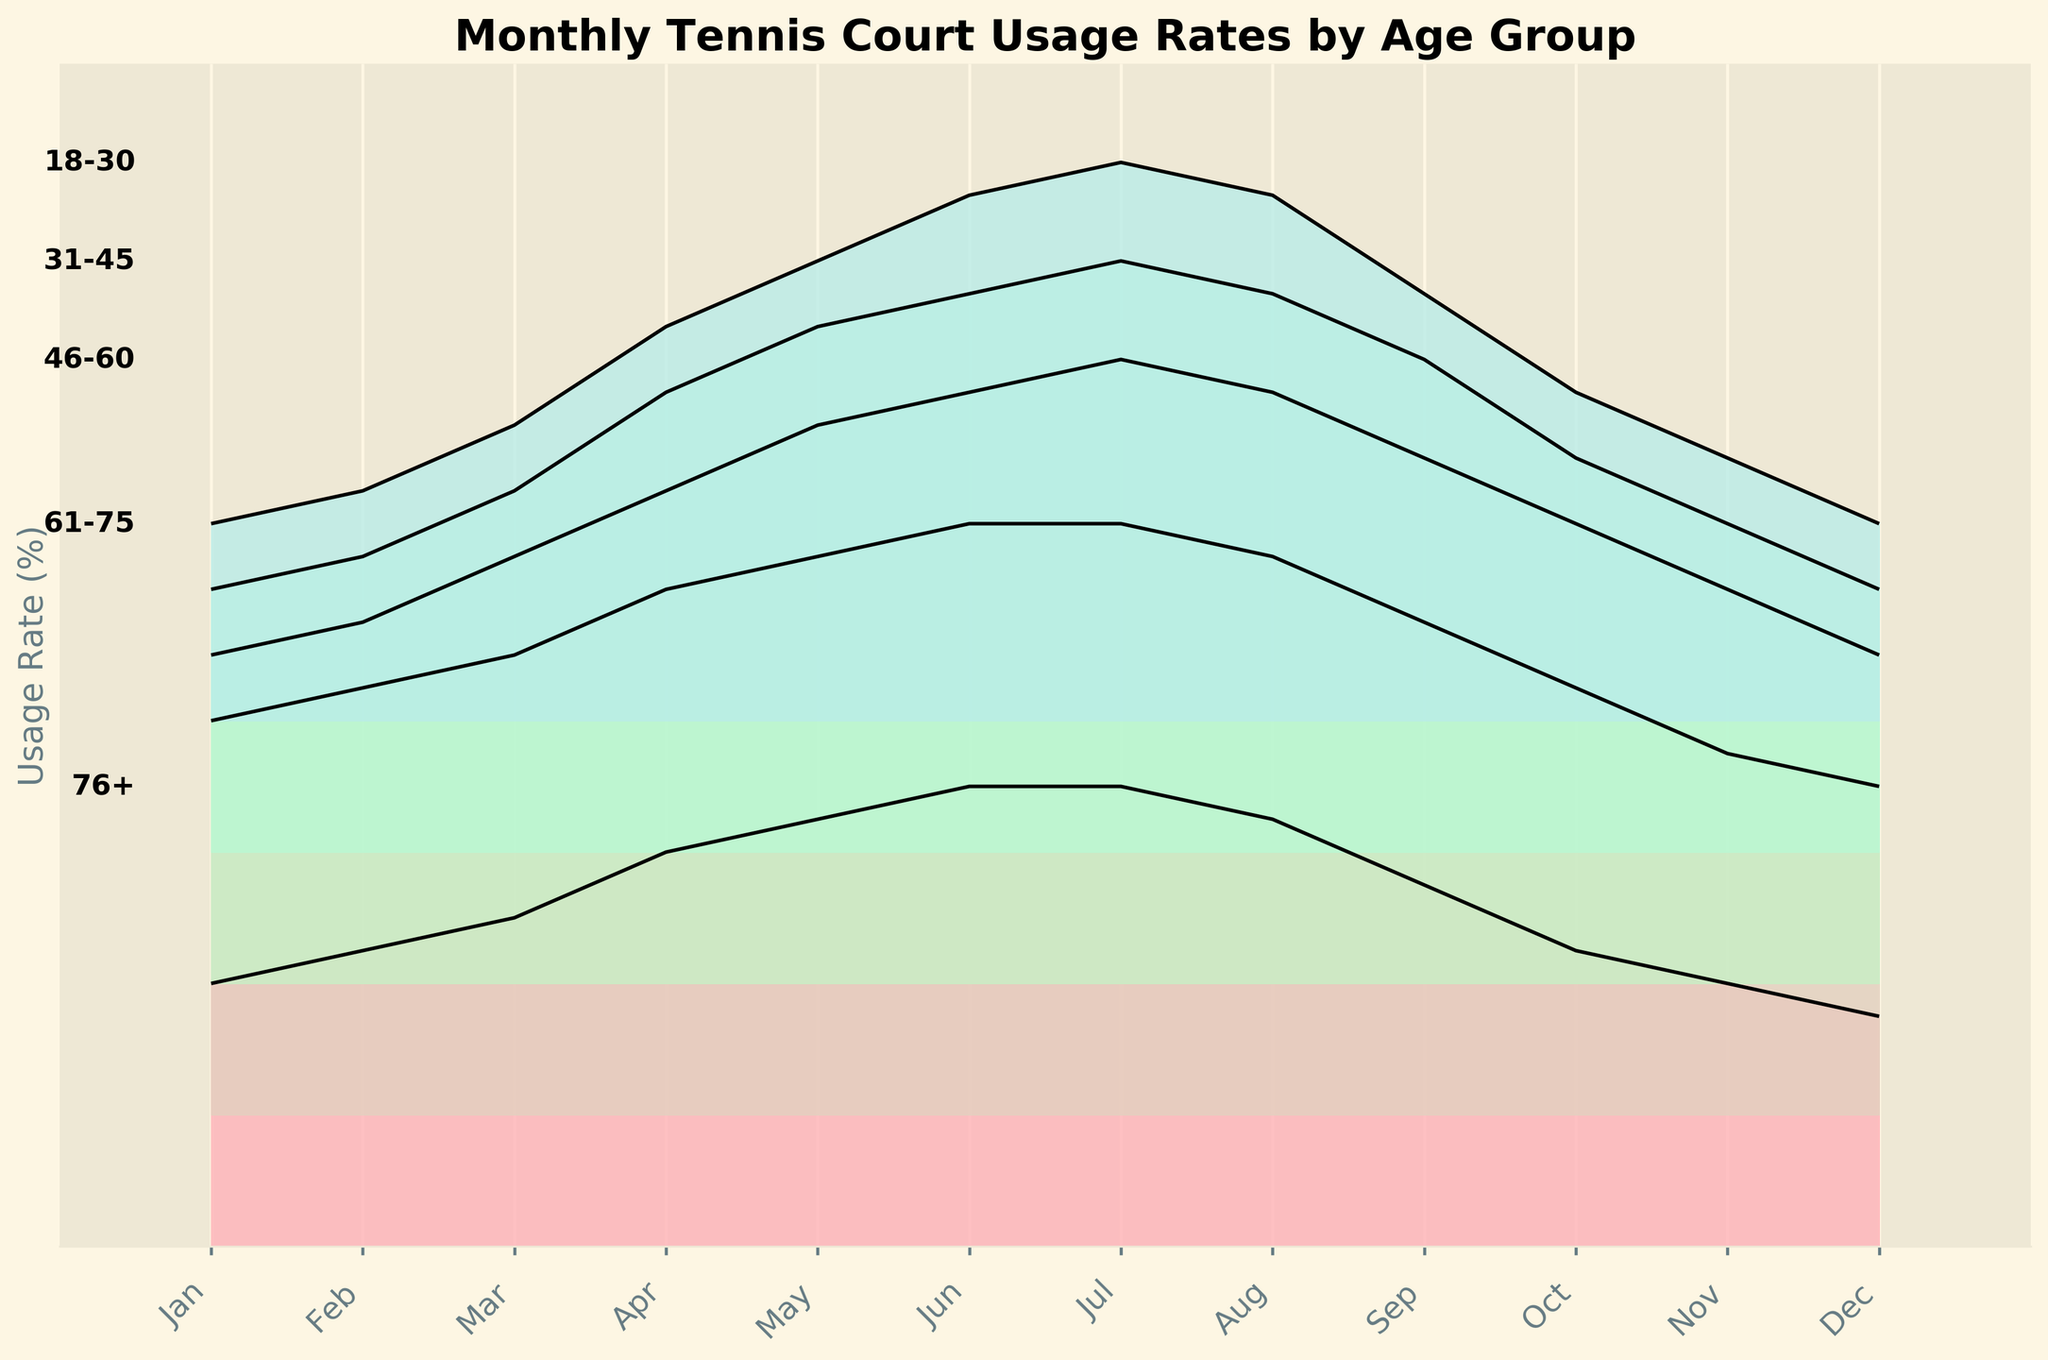What is the title of the figure? The title of the figure is displayed at the top and reads "Monthly Tennis Court Usage Rates by Age Group."
Answer: Monthly Tennis Court Usage Rates by Age Group Which age group has the highest usage rate in July? By visually inspecting the peak values in July, we can see that the age group "46-60" has the highest usage rate.
Answer: 46-60 How does the usage rate for the "18-30" age group change from January to December? The usage rate for "18-30" starts at 30% in January, rises and peaks at 85% in July, and then decreases back to 30% in December.
Answer: It increases until July and then decreases What is the difference in usage rates between "61-75" and "76+" age groups in December? The usage rate for the "61-75" age group in December is 50%, and for "76+" it is 35%. The difference is 50% - 35% = 15%.
Answer: 15% Which age group shows the most significant increase in usage rate from January to June? By examining the slope of the lines from January to June, we see that the "46-60" age group increases from 50% to 90%, which is a 40% increase, the largest among the groups.
Answer: 46-60 What is the average usage rate for the "31-45" age group from January to December? The "31-45" group values are [40, 45, 55, 70, 80, 85, 90, 85, 75, 60, 50, 40]. Summing these values gives 775. Dividing by 12 gives an average of 64.58%.
Answer: 64.58% Is the usage rate higher for "61-75" or "76+" in May? The usage rate for "61-75" in May is 85%, and for "76+" it is 65%. Therefore, "61-75" has a higher usage rate in May.
Answer: 61-75 Which month shows the peak usage for the most age groups? Most age groups "18-30," "31-45," and "46-60" peak in July, while "61-75" and "76+" do not show clear single peaks for most groups as July.
Answer: July In what months does the "31-45" age group's usage rate equal or exceed 85%? The usage rate for the "31-45" age group equals or exceeds 85% in June (85%), July (90%), and August (85%).
Answer: June, July, August 